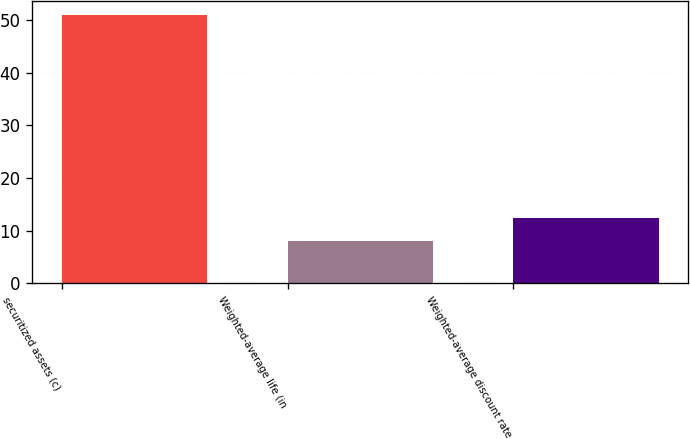<chart> <loc_0><loc_0><loc_500><loc_500><bar_chart><fcel>securitized assets (c)<fcel>Weighted-average life (in<fcel>Weighted-average discount rate<nl><fcel>51<fcel>8.1<fcel>12.39<nl></chart> 